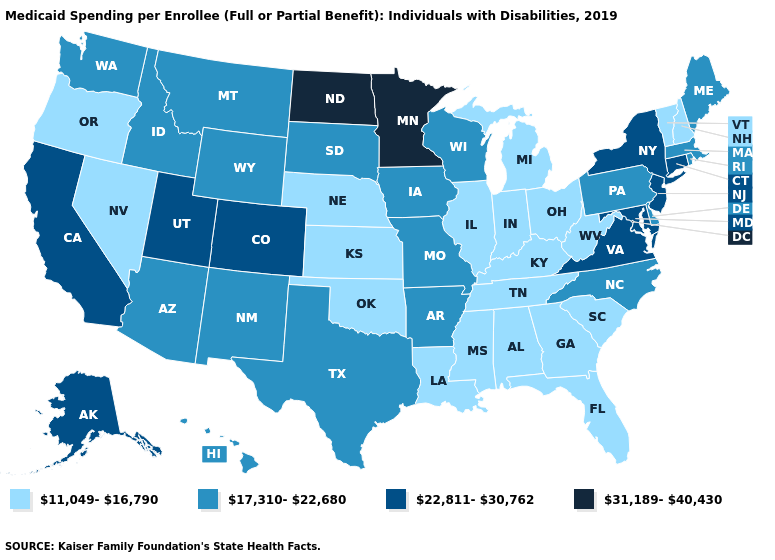How many symbols are there in the legend?
Be succinct. 4. Does Minnesota have the highest value in the USA?
Keep it brief. Yes. Name the states that have a value in the range 22,811-30,762?
Be succinct. Alaska, California, Colorado, Connecticut, Maryland, New Jersey, New York, Utah, Virginia. Name the states that have a value in the range 31,189-40,430?
Write a very short answer. Minnesota, North Dakota. Which states have the lowest value in the MidWest?
Write a very short answer. Illinois, Indiana, Kansas, Michigan, Nebraska, Ohio. Name the states that have a value in the range 11,049-16,790?
Write a very short answer. Alabama, Florida, Georgia, Illinois, Indiana, Kansas, Kentucky, Louisiana, Michigan, Mississippi, Nebraska, Nevada, New Hampshire, Ohio, Oklahoma, Oregon, South Carolina, Tennessee, Vermont, West Virginia. What is the value of California?
Concise answer only. 22,811-30,762. What is the value of Nevada?
Short answer required. 11,049-16,790. Name the states that have a value in the range 17,310-22,680?
Answer briefly. Arizona, Arkansas, Delaware, Hawaii, Idaho, Iowa, Maine, Massachusetts, Missouri, Montana, New Mexico, North Carolina, Pennsylvania, Rhode Island, South Dakota, Texas, Washington, Wisconsin, Wyoming. Among the states that border Tennessee , does Virginia have the lowest value?
Concise answer only. No. Name the states that have a value in the range 17,310-22,680?
Give a very brief answer. Arizona, Arkansas, Delaware, Hawaii, Idaho, Iowa, Maine, Massachusetts, Missouri, Montana, New Mexico, North Carolina, Pennsylvania, Rhode Island, South Dakota, Texas, Washington, Wisconsin, Wyoming. Name the states that have a value in the range 17,310-22,680?
Quick response, please. Arizona, Arkansas, Delaware, Hawaii, Idaho, Iowa, Maine, Massachusetts, Missouri, Montana, New Mexico, North Carolina, Pennsylvania, Rhode Island, South Dakota, Texas, Washington, Wisconsin, Wyoming. Which states have the lowest value in the USA?
Write a very short answer. Alabama, Florida, Georgia, Illinois, Indiana, Kansas, Kentucky, Louisiana, Michigan, Mississippi, Nebraska, Nevada, New Hampshire, Ohio, Oklahoma, Oregon, South Carolina, Tennessee, Vermont, West Virginia. What is the value of Nevada?
Short answer required. 11,049-16,790. 